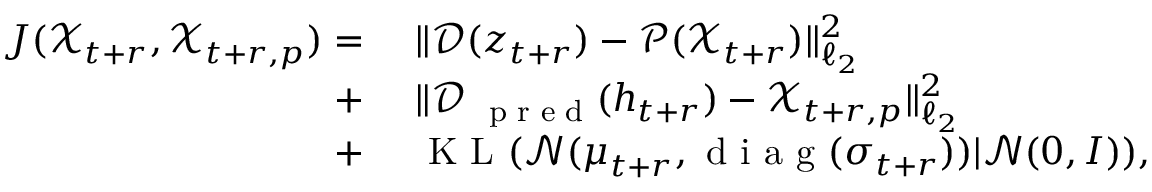<formula> <loc_0><loc_0><loc_500><loc_500>\begin{array} { r l } { J ( \mathcal { X } _ { t + r } , \ m a t h s c r X _ { t + r , p } ) = } & \| \mathcal { D } ( \boldsymbol z _ { t + r } ) - \mathcal { P } ( \mathcal { X } _ { t + r } ) \| _ { \ell _ { 2 } } ^ { 2 } } \\ { + } & \| \mathcal { D } _ { p r e d } ( \boldsymbol h _ { t + r } ) - \ m a t h s c r X _ { t + r , p } \| _ { \ell _ { 2 } } ^ { 2 } } \\ { + } & K L ( \mathcal { N } ( \boldsymbol \mu _ { t + r } , d i a g ( \boldsymbol \sigma _ { t + r } ) ) | \mathcal { N } ( \boldsymbol 0 , \boldsymbol I ) ) , } \end{array}</formula> 